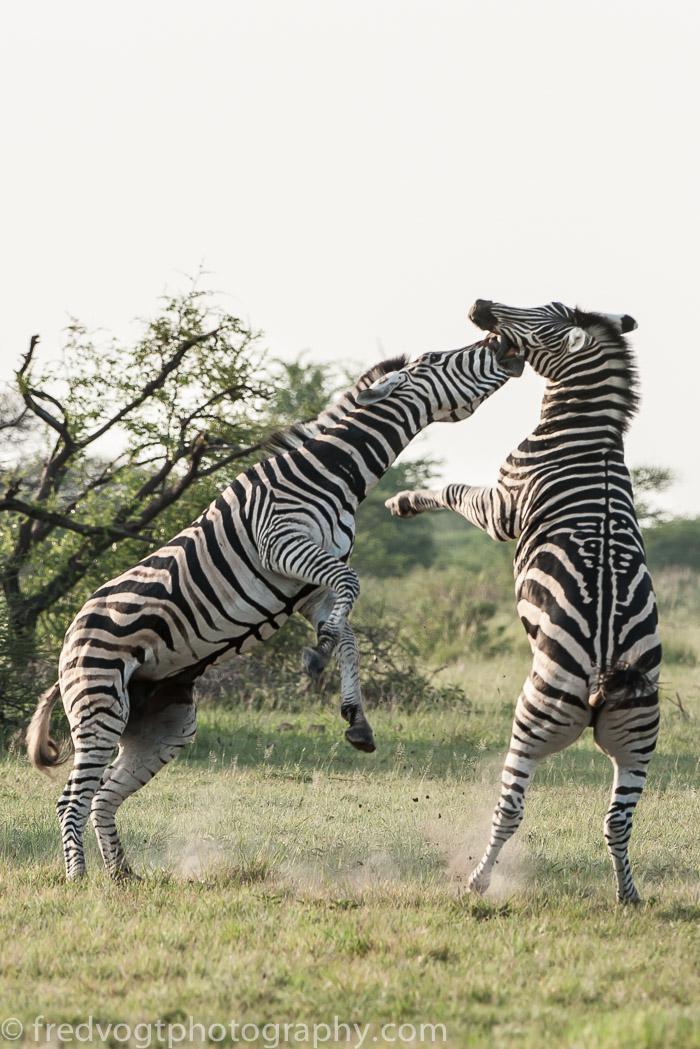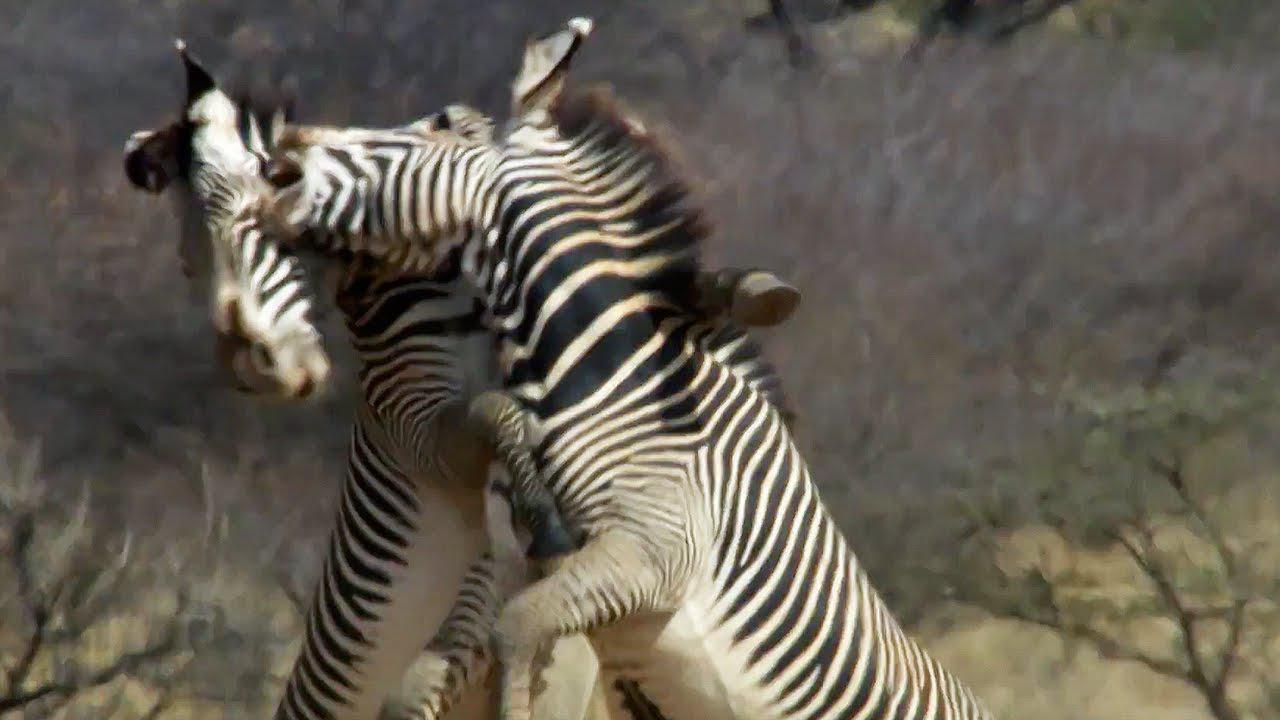The first image is the image on the left, the second image is the image on the right. Considering the images on both sides, is "The right image contains exactly two zebras." valid? Answer yes or no. Yes. The first image is the image on the left, the second image is the image on the right. For the images shown, is this caption "Two zebras play with each other in a field in each of the images." true? Answer yes or no. Yes. 